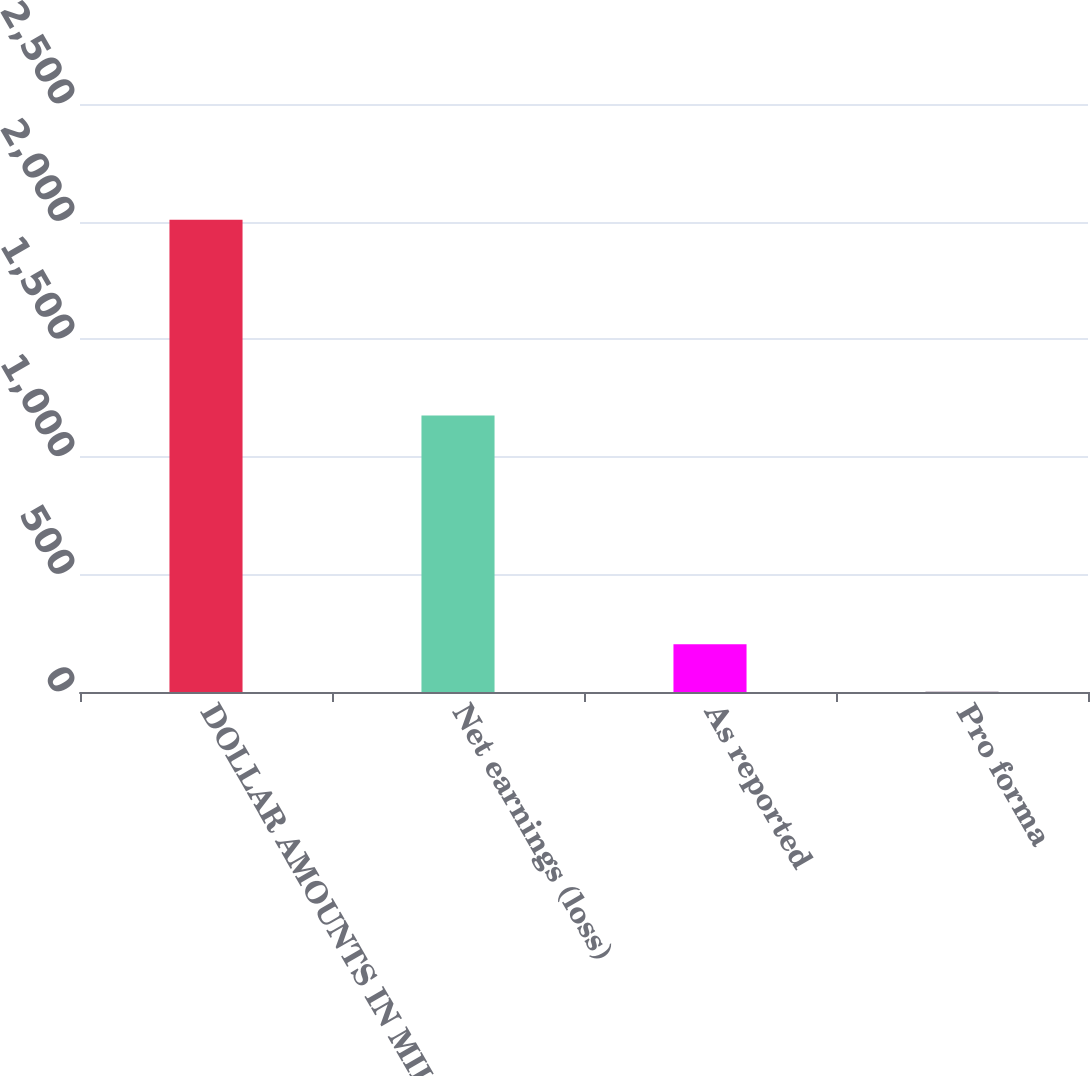Convert chart to OTSL. <chart><loc_0><loc_0><loc_500><loc_500><bar_chart><fcel>DOLLAR AMOUNTS IN MILLIONS<fcel>Net earnings (loss)<fcel>As reported<fcel>Pro forma<nl><fcel>2008<fcel>1176<fcel>202.78<fcel>2.2<nl></chart> 